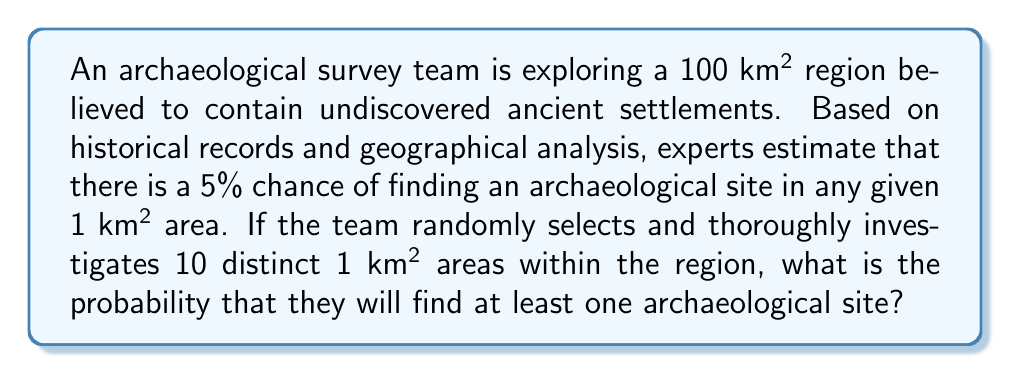Give your solution to this math problem. Let's approach this step-by-step:

1) First, we need to determine the probability of not finding a site in a single 1 km² area:
   $P(\text{no site}) = 1 - P(\text{site}) = 1 - 0.05 = 0.95$

2) Now, we need to find the probability of not finding a site in all 10 selected areas:
   $P(\text{no sites in 10 areas}) = (0.95)^{10}$

3) The probability of finding at least one site is the complement of finding no sites:
   $P(\text{at least one site}) = 1 - P(\text{no sites in 10 areas})$

4) Let's calculate:
   $P(\text{at least one site}) = 1 - (0.95)^{10}$
   $= 1 - 0.5987369392$
   $= 0.4012630608$

5) Converting to a percentage:
   $0.4012630608 \times 100\% = 40.13\%$ (rounded to two decimal places)

This means there's approximately a 40.13% chance that the team will find at least one archaeological site in their survey of 10 randomly selected 1 km² areas.
Answer: 40.13% 